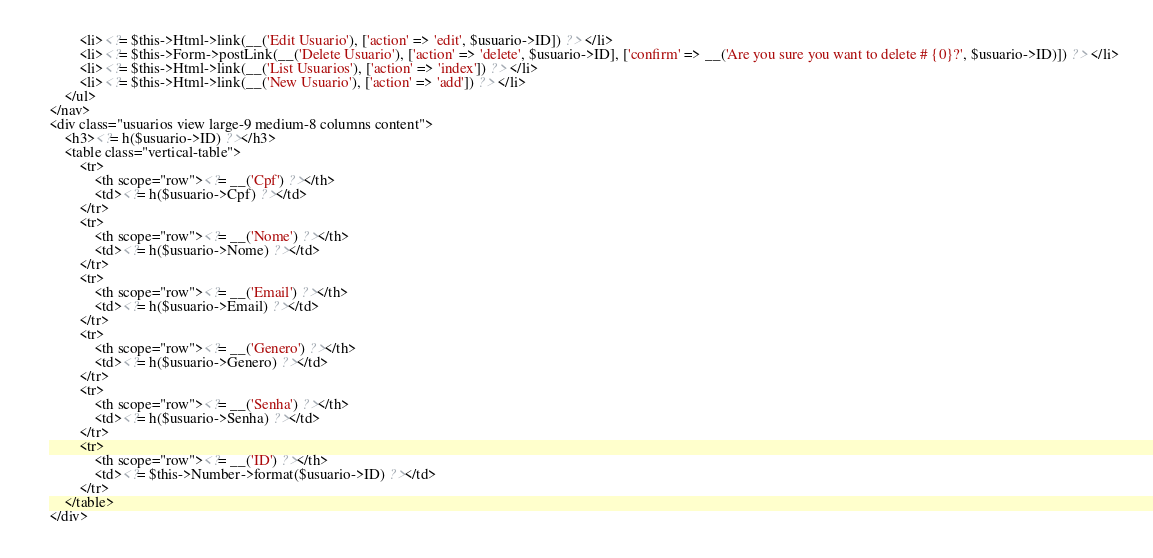Convert code to text. <code><loc_0><loc_0><loc_500><loc_500><_PHP_>        <li><?= $this->Html->link(__('Edit Usuario'), ['action' => 'edit', $usuario->ID]) ?> </li>
        <li><?= $this->Form->postLink(__('Delete Usuario'), ['action' => 'delete', $usuario->ID], ['confirm' => __('Are you sure you want to delete # {0}?', $usuario->ID)]) ?> </li>
        <li><?= $this->Html->link(__('List Usuarios'), ['action' => 'index']) ?> </li>
        <li><?= $this->Html->link(__('New Usuario'), ['action' => 'add']) ?> </li>
    </ul>
</nav>
<div class="usuarios view large-9 medium-8 columns content">
    <h3><?= h($usuario->ID) ?></h3>
    <table class="vertical-table">
        <tr>
            <th scope="row"><?= __('Cpf') ?></th>
            <td><?= h($usuario->Cpf) ?></td>
        </tr>
        <tr>
            <th scope="row"><?= __('Nome') ?></th>
            <td><?= h($usuario->Nome) ?></td>
        </tr>
        <tr>
            <th scope="row"><?= __('Email') ?></th>
            <td><?= h($usuario->Email) ?></td>
        </tr>
        <tr>
            <th scope="row"><?= __('Genero') ?></th>
            <td><?= h($usuario->Genero) ?></td>
        </tr>
        <tr>
            <th scope="row"><?= __('Senha') ?></th>
            <td><?= h($usuario->Senha) ?></td>
        </tr>
        <tr>
            <th scope="row"><?= __('ID') ?></th>
            <td><?= $this->Number->format($usuario->ID) ?></td>
        </tr>
    </table>
</div>
</code> 